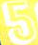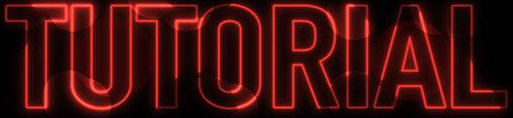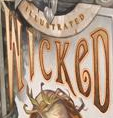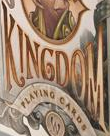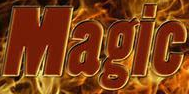Read the text from these images in sequence, separated by a semicolon. 5; TUTORIAL; WICKeD; KINGDOM; Magic 